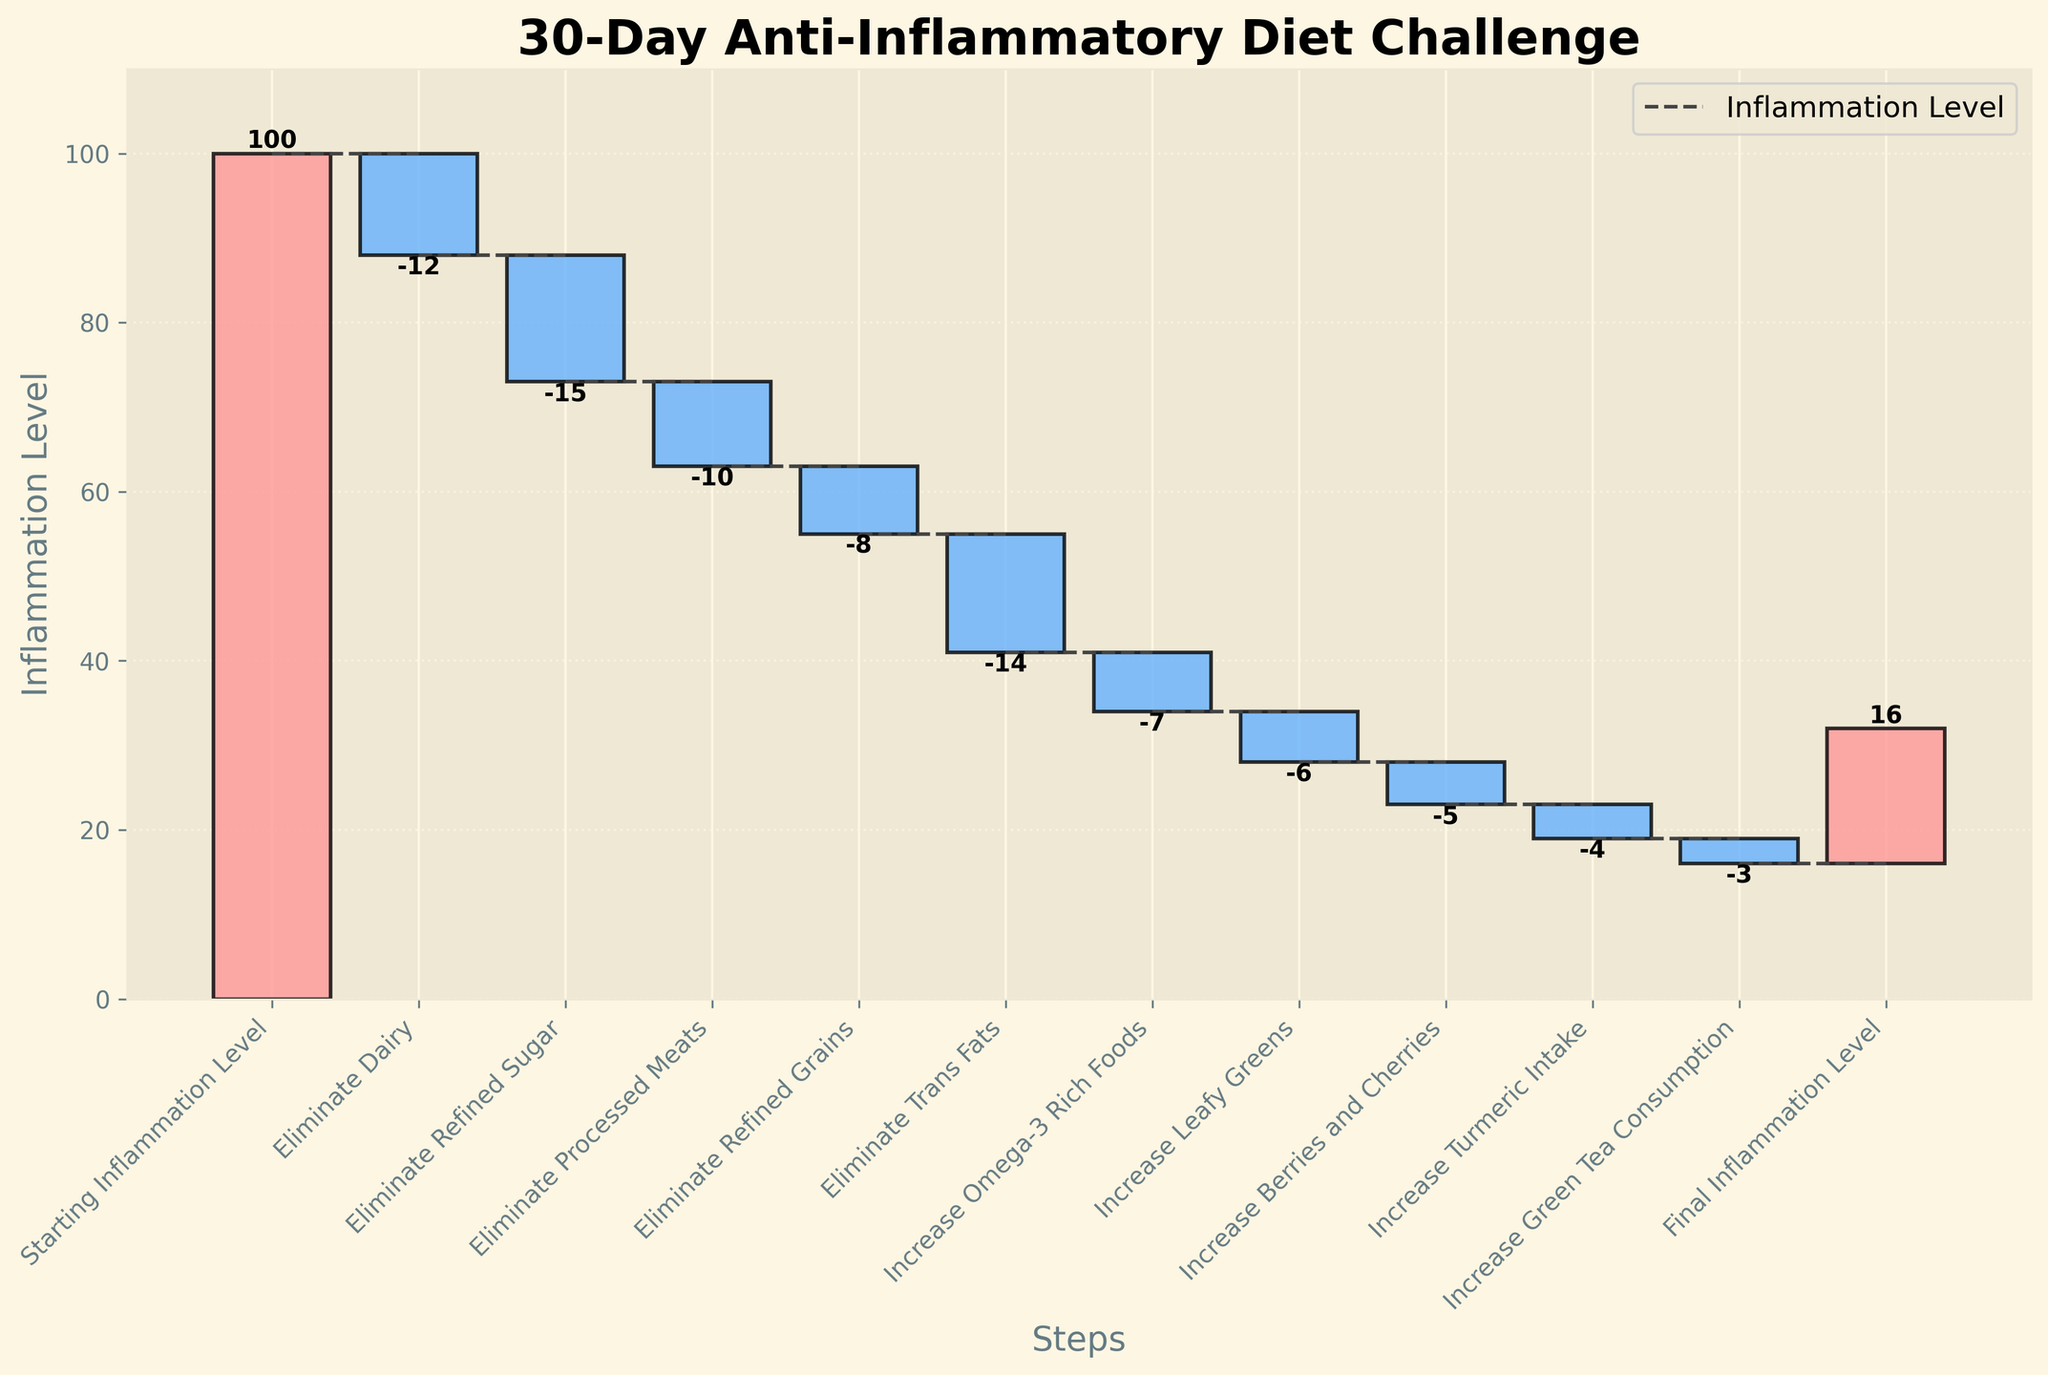What's the title of the chart? The title of the chart is displayed at the top and reads "30-Day Anti-Inflammatory Diet Challenge".
Answer: 30-Day Anti-Inflammatory Diet Challenge How many categories are there in the chart? By counting the number of bars, we see there are eleven categories on the x-axis.
Answer: 11 Which category had the greatest single reduction in inflammation levels? By examining the height and color of the bars, the category 'Eliminate Refined Sugar' shows the most substantial single drop with a value of -15.
Answer: Eliminate Refined Sugar What is the final inflammation level at the end of the challenge? The last category on the x-axis is 'Final Inflammation Level', and the corresponding value is shown as 16.
Answer: 16 What cumulative impact did eliminating dairy and refined sugar have on inflammation levels? By summing the values for 'Eliminate Dairy' (-12) and 'Eliminate Refined Sugar' (-15), we get: -12 + -15 = -27.
Answer: -27 What are the inflammation levels before and after eliminating processed meats? Before eliminating processed meats, the cumulative level is 73. After eliminating processed meats with a value of -10, the level is 63.
Answer: 73 and 63 Which step had the least impact on reducing inflammation levels? The category with the smallest absolute value in the negative direction is 'Increase Green Tea Consumption' with -3.
Answer: Increase Green Tea Consumption Did eliminating refined grains have a greater impact than increasing berries and cherries? The value for eliminating refined grains is -8, while increasing berries and cherries is -5. Since -8 is less than -5, eliminating refined grains had a greater impact.
Answer: Yes By how much did eliminating trans fats reduce the inflammation level compared to increasing omega-3 rich foods? Eliminating trans fats reduced the level by -14 and increasing omega-3 rich foods by -7. The difference is -14 - (-7) = -7.
Answer: 7 What is the net effect of all the steps combined on the inflammation level? Starting level is 100 and the final level is 16. The net effect is 100 - 16 = 84.
Answer: 84 